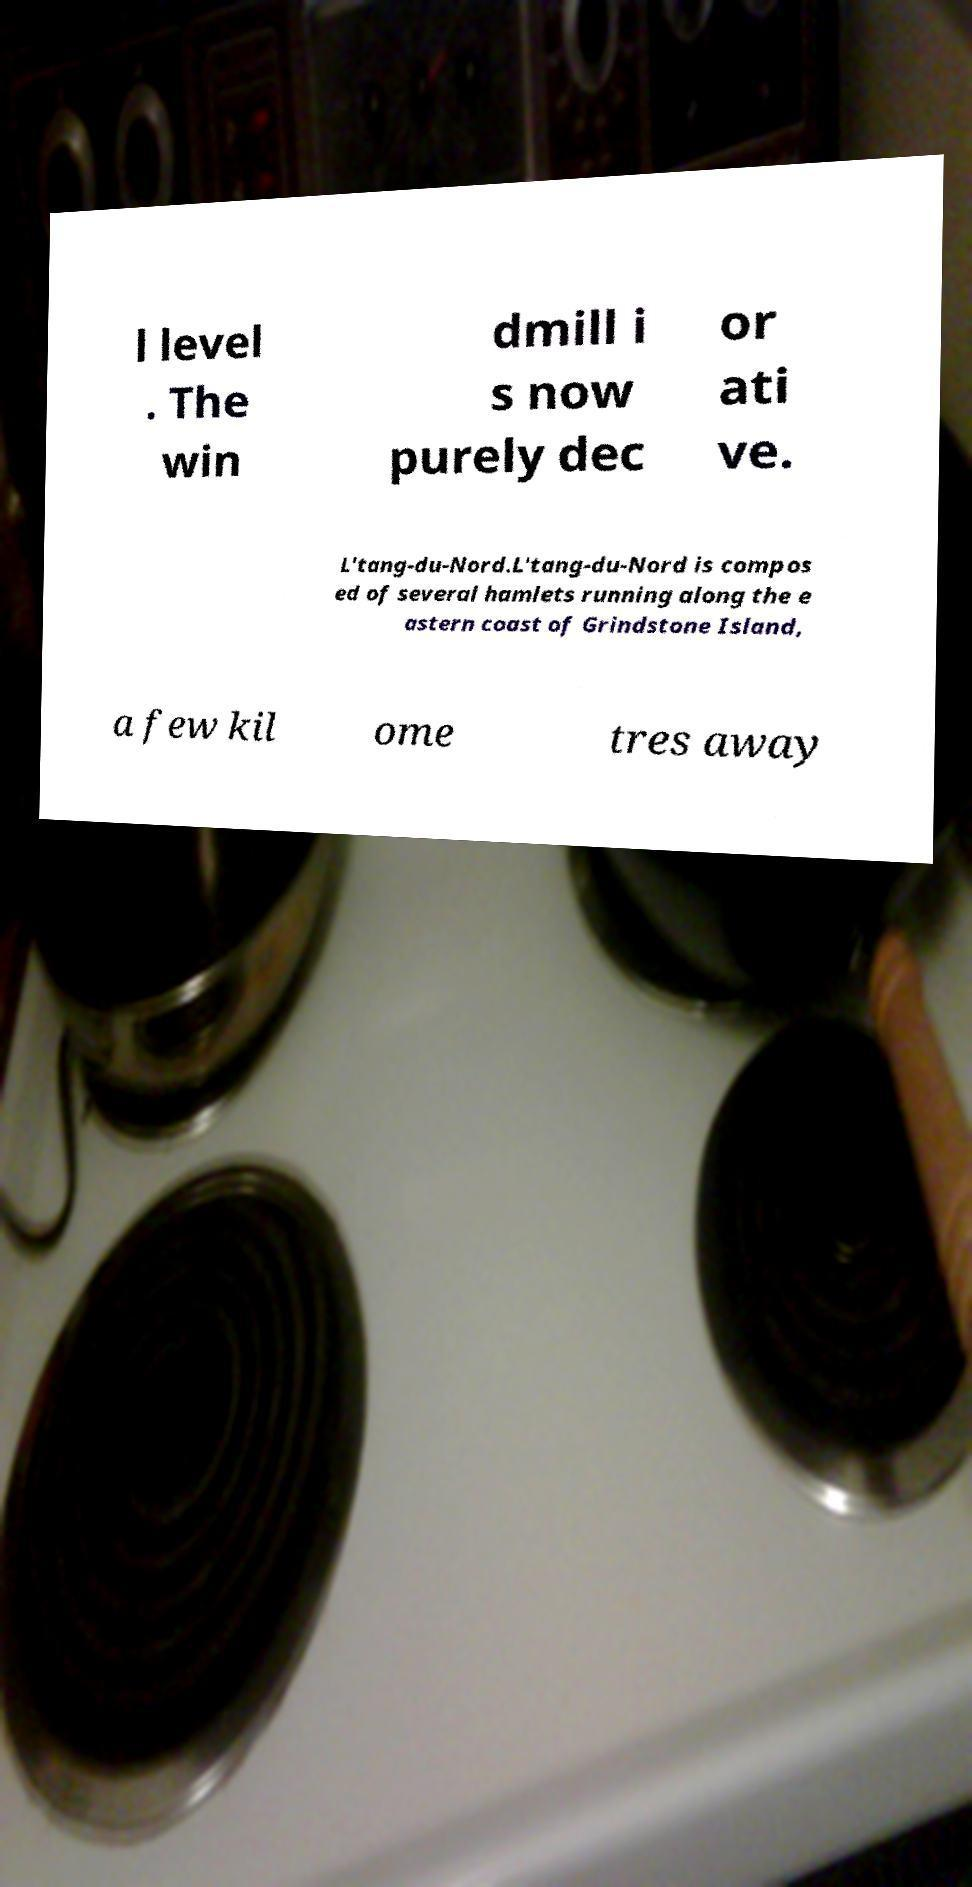Can you accurately transcribe the text from the provided image for me? l level . The win dmill i s now purely dec or ati ve. L'tang-du-Nord.L'tang-du-Nord is compos ed of several hamlets running along the e astern coast of Grindstone Island, a few kil ome tres away 